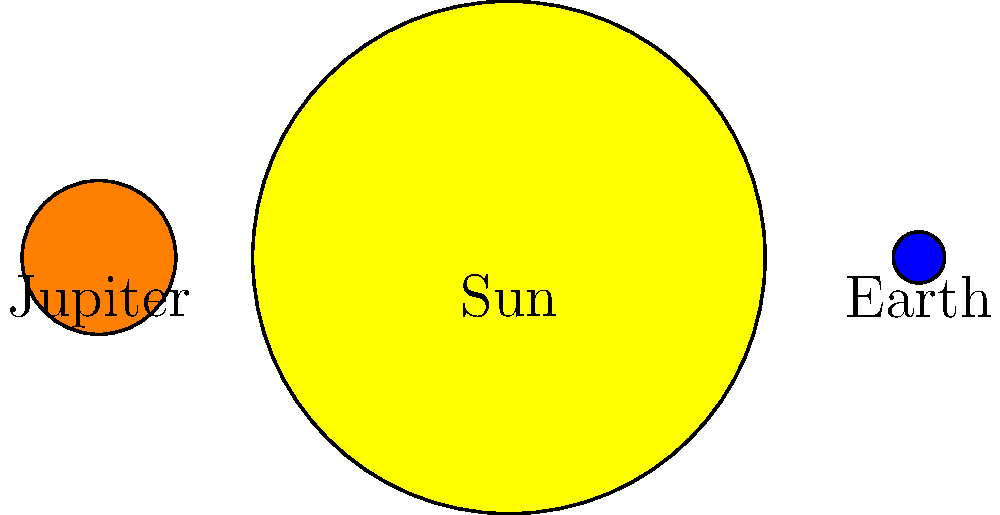Your child is working on an astronomy project about planetary sizes. In the diagram above, the Sun, Earth, and Jupiter are represented by scaled circles. If the Sun's radius is 10 times that of Earth in this model, approximately how many times larger is Jupiter's radius compared to Earth's? Let's approach this step-by-step:

1. We're told that the Sun's radius is 10 times Earth's radius in this model.

2. Looking at the diagram, we can see that Earth is the smallest circle, Jupiter is larger, and the Sun is the largest.

3. To estimate Jupiter's size relative to Earth, we need to compare their radii in the diagram.

4. Earth's radius appears to be about 1/3 of Jupiter's radius.

5. To express this as a multiple, we can say that Jupiter's radius is about 3 times Earth's radius.

6. We can verify this by comparing to the Sun:
   - Earth's radius is 1/10 of the Sun's
   - Jupiter's radius looks to be about 3/10 of the Sun's

7. Therefore, Jupiter's radius is approximately 3 times larger than Earth's radius in this model.

This aligns with real astronomical data, where Jupiter's radius is about 11 times Earth's radius, and the Sun's radius is about 109 times Earth's radius. The diagram is a simplified model but gives a good general idea of the relative sizes.
Answer: 3 times 